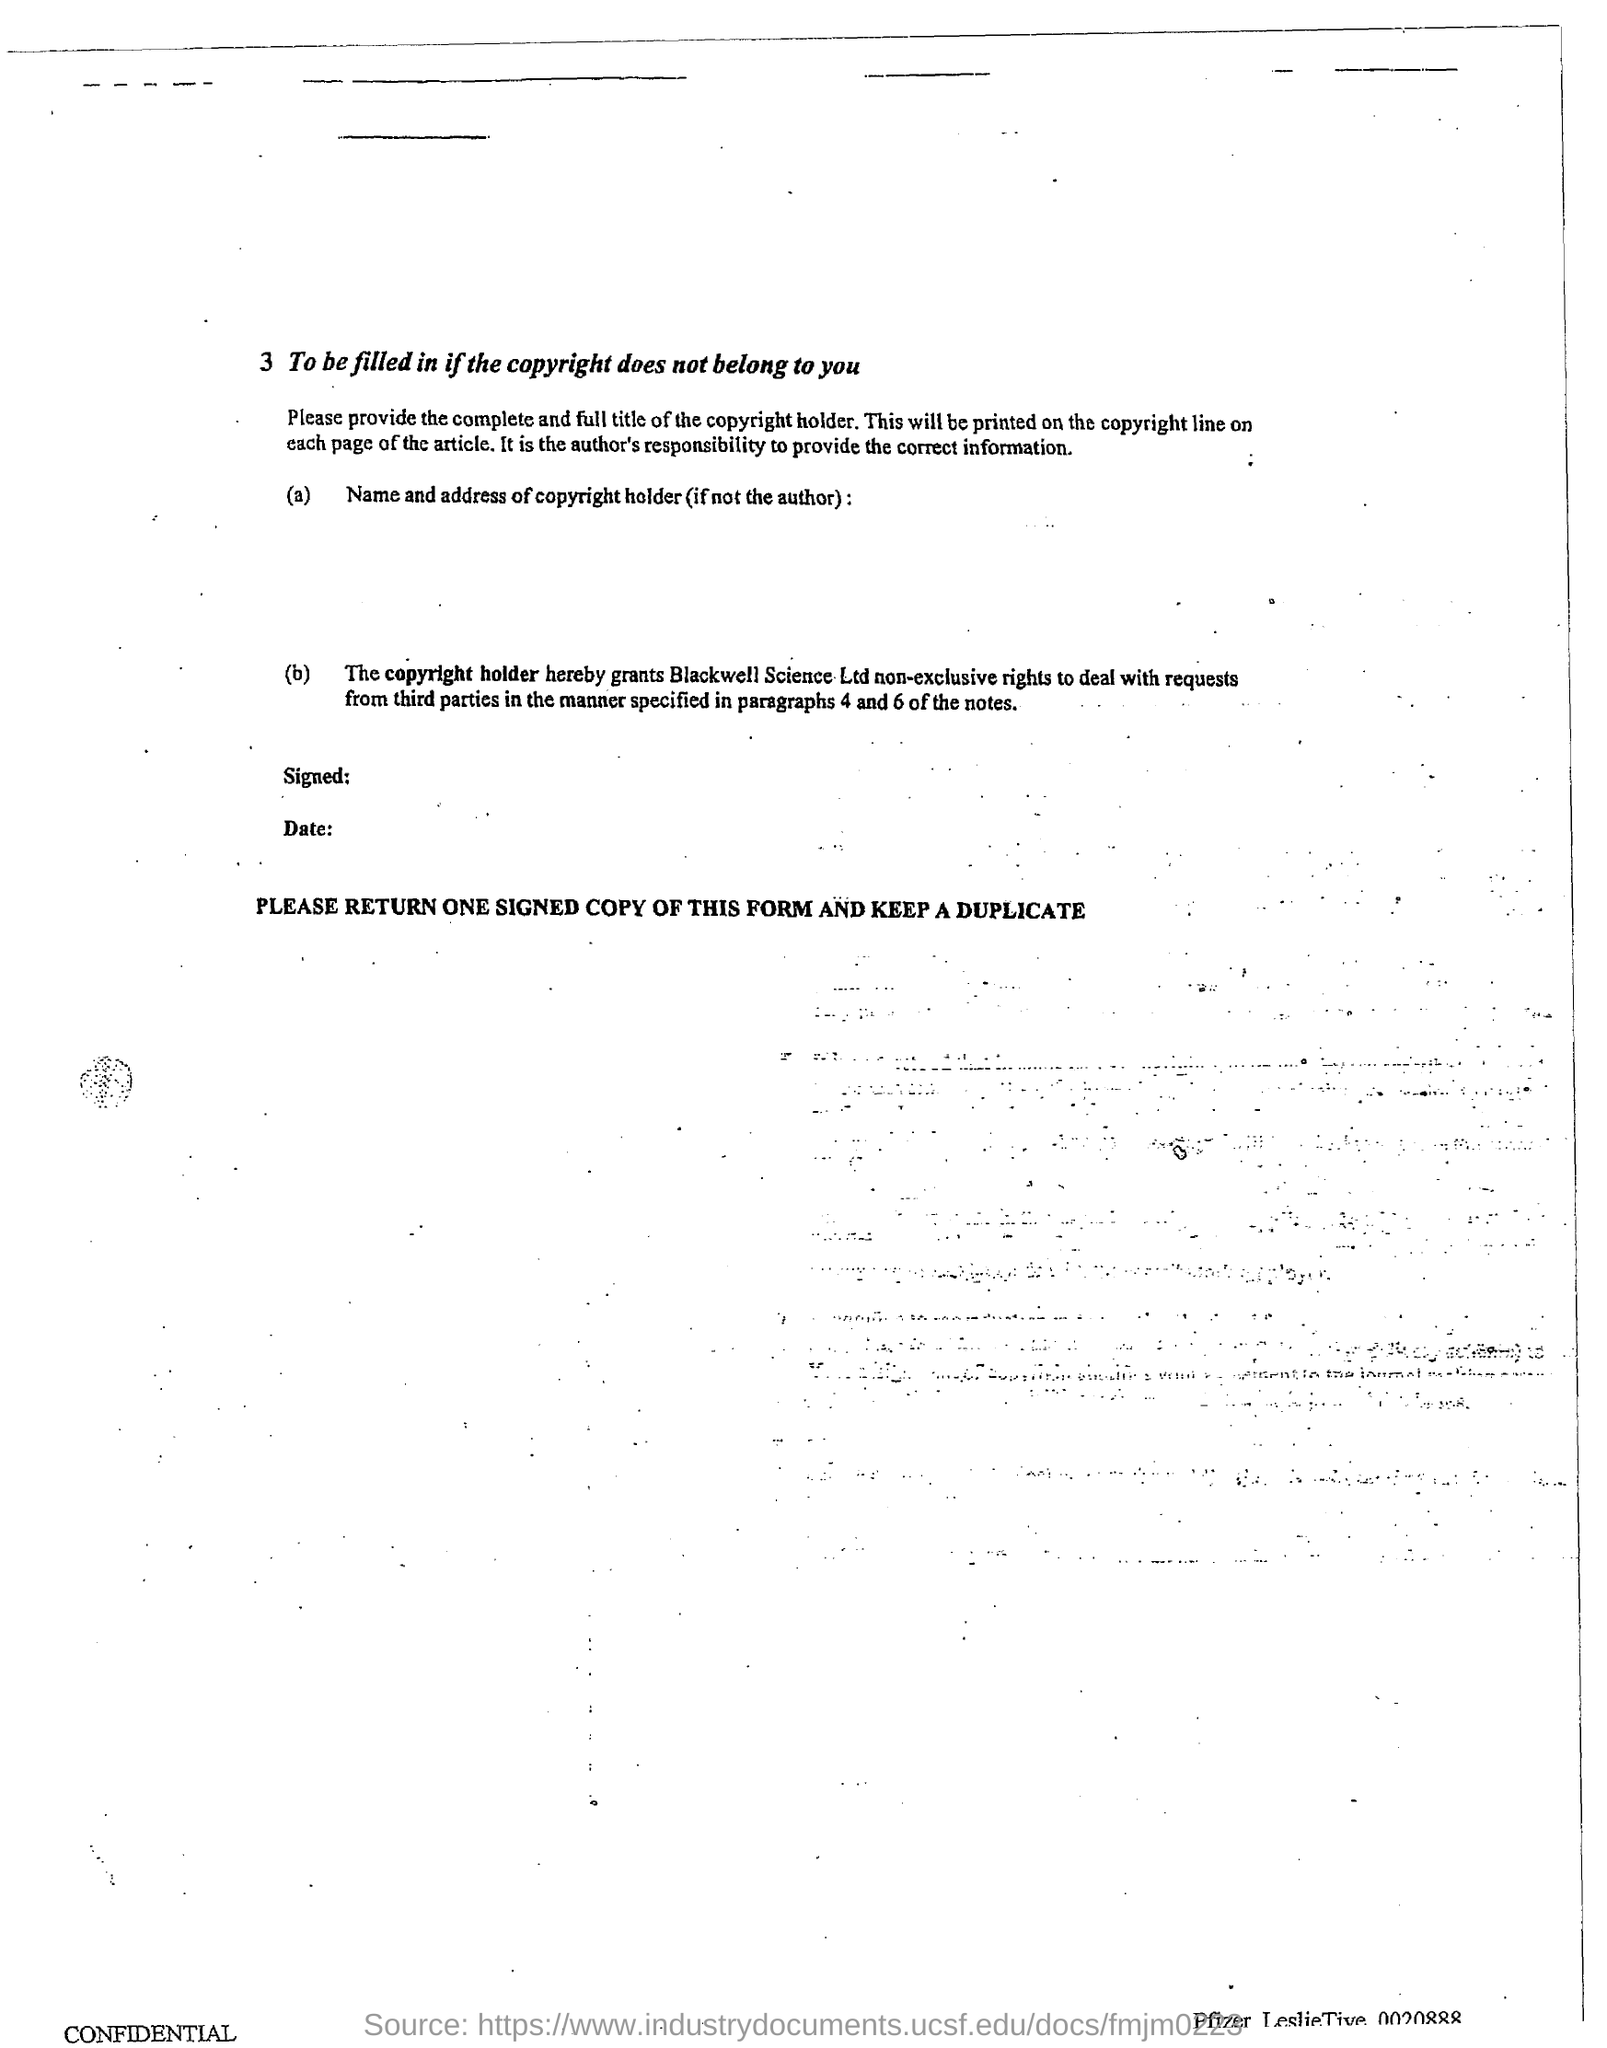Whose responsibility is to provide the correct information?
Your response must be concise. Author's. Who grants Blackwell Science Ltd non-exclusive rights to deal with requests from third parties?
Keep it short and to the point. The copyright holder. 